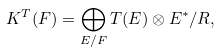Convert formula to latex. <formula><loc_0><loc_0><loc_500><loc_500>K ^ { T } ( F ) = \bigoplus _ { E / F } T ( E ) \otimes E ^ { * } / R ,</formula> 